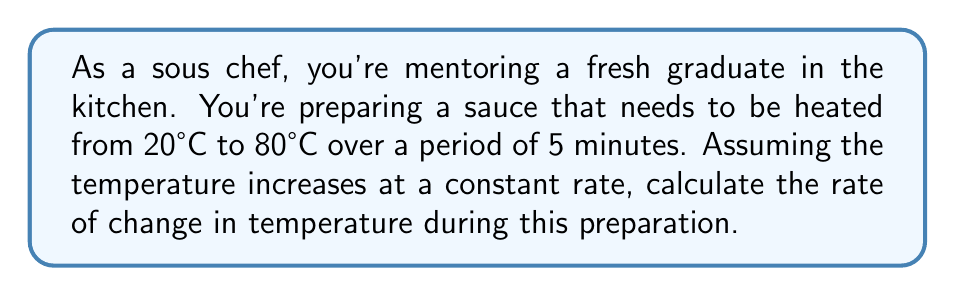Give your solution to this math problem. Let's approach this step-by-step:

1) First, we need to identify the key information:
   - Initial temperature: 20°C
   - Final temperature: 80°C
   - Time period: 5 minutes

2) The rate of change is given by the formula:

   $$ \text{Rate of change} = \frac{\text{Change in quantity}}{\text{Change in time}} $$

3) In this case:
   - Change in temperature = Final temperature - Initial temperature
     $$ \Delta T = 80°C - 20°C = 60°C $$
   - Change in time = 5 minutes

4) Substituting these values into our formula:

   $$ \text{Rate of change} = \frac{60°C}{5 \text{ minutes}} $$

5) Simplifying:

   $$ \text{Rate of change} = 12°C/\text{minute} $$

This means the temperature is increasing at a constant rate of 12°C per minute.
Answer: $12°C/\text{minute}$ 